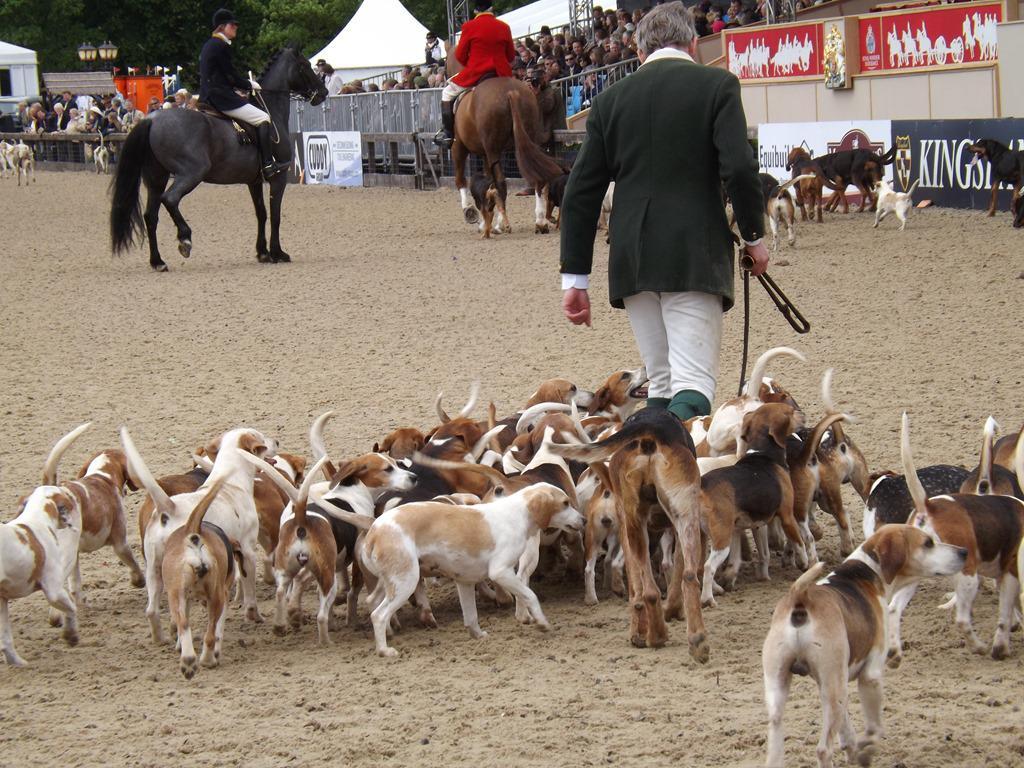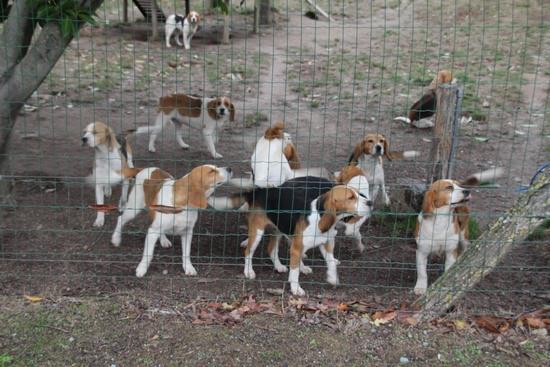The first image is the image on the left, the second image is the image on the right. For the images displayed, is the sentence "Right image shows at least one man in white breeches with a pack of hounds." factually correct? Answer yes or no. No. The first image is the image on the left, the second image is the image on the right. Given the left and right images, does the statement "There is a single vehicle shown in one of the images." hold true? Answer yes or no. No. 